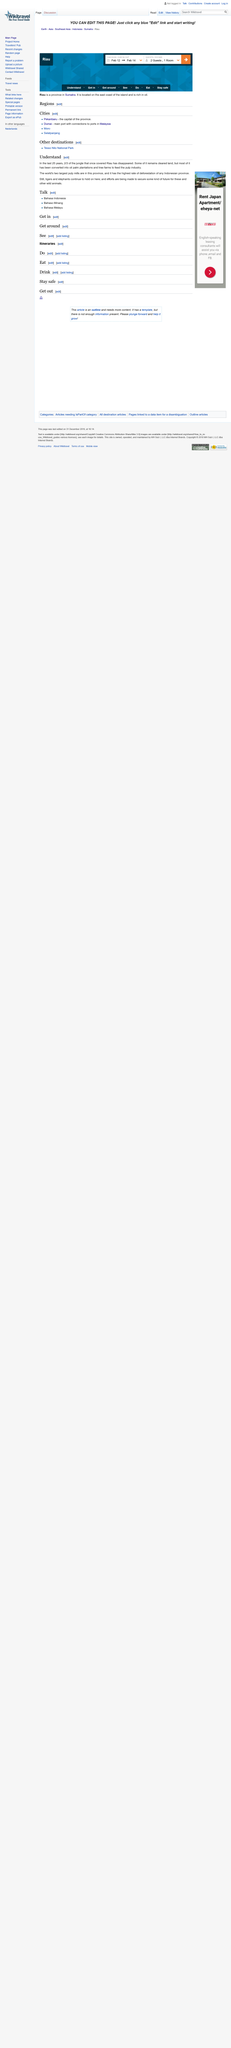Draw attention to some important aspects in this diagram. The world's largest pulp mills are located in the province of Riau. Tree farms are used to feed the pulp industry, where they are cut down and processed into pulp for various commercial purposes. According to the data, 2/3 of the jungle in Riau has disappeared. 